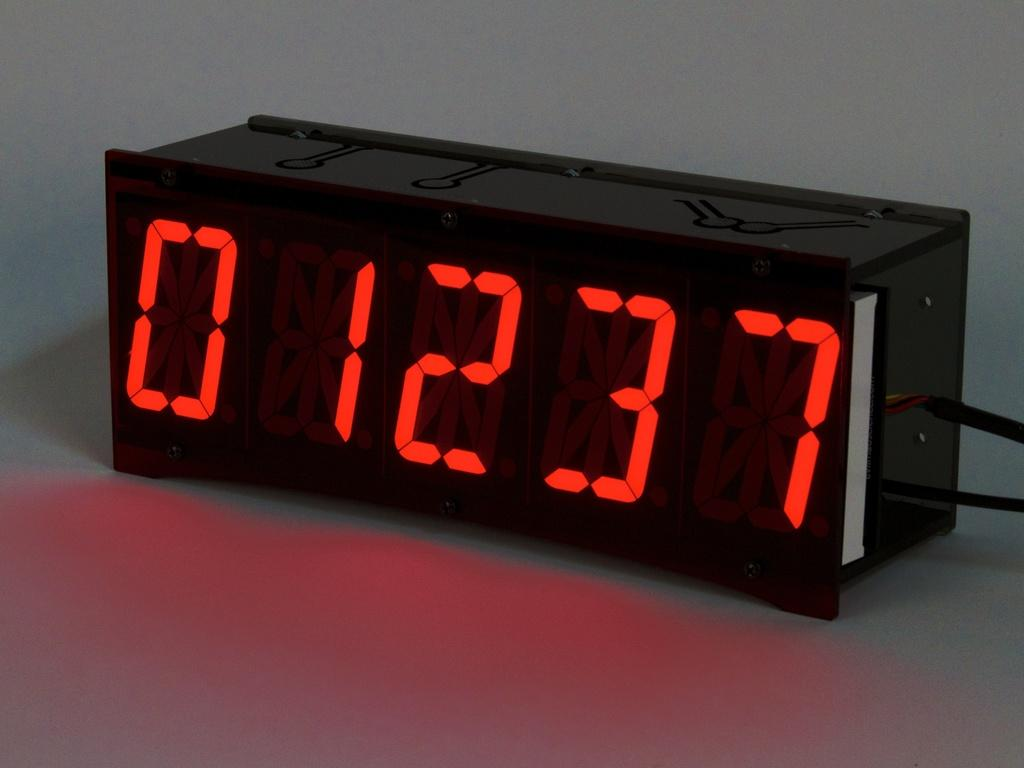Provide a one-sentence caption for the provided image. Numbers 01237 are shown in neon red on a black background. 